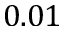<formula> <loc_0><loc_0><loc_500><loc_500>0 . 0 1</formula> 